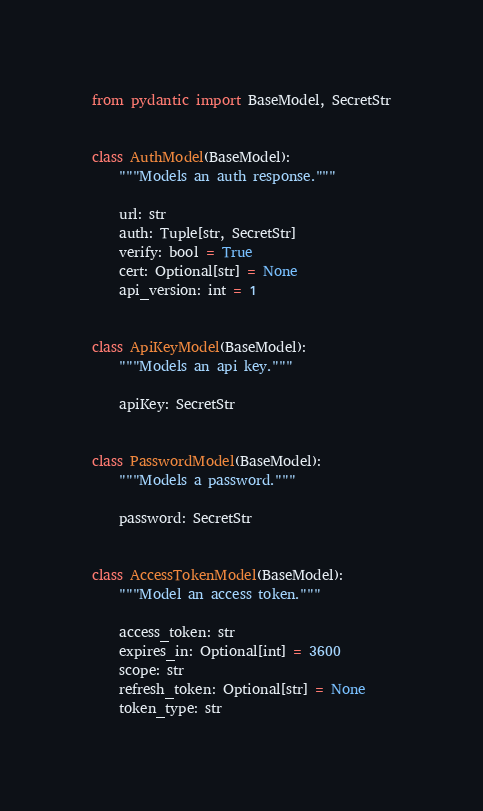<code> <loc_0><loc_0><loc_500><loc_500><_Python_>from pydantic import BaseModel, SecretStr


class AuthModel(BaseModel):
    """Models an auth response."""

    url: str
    auth: Tuple[str, SecretStr]
    verify: bool = True
    cert: Optional[str] = None
    api_version: int = 1


class ApiKeyModel(BaseModel):
    """Models an api key."""

    apiKey: SecretStr


class PasswordModel(BaseModel):
    """Models a password."""

    password: SecretStr


class AccessTokenModel(BaseModel):
    """Model an access token."""

    access_token: str
    expires_in: Optional[int] = 3600
    scope: str
    refresh_token: Optional[str] = None
    token_type: str
</code> 